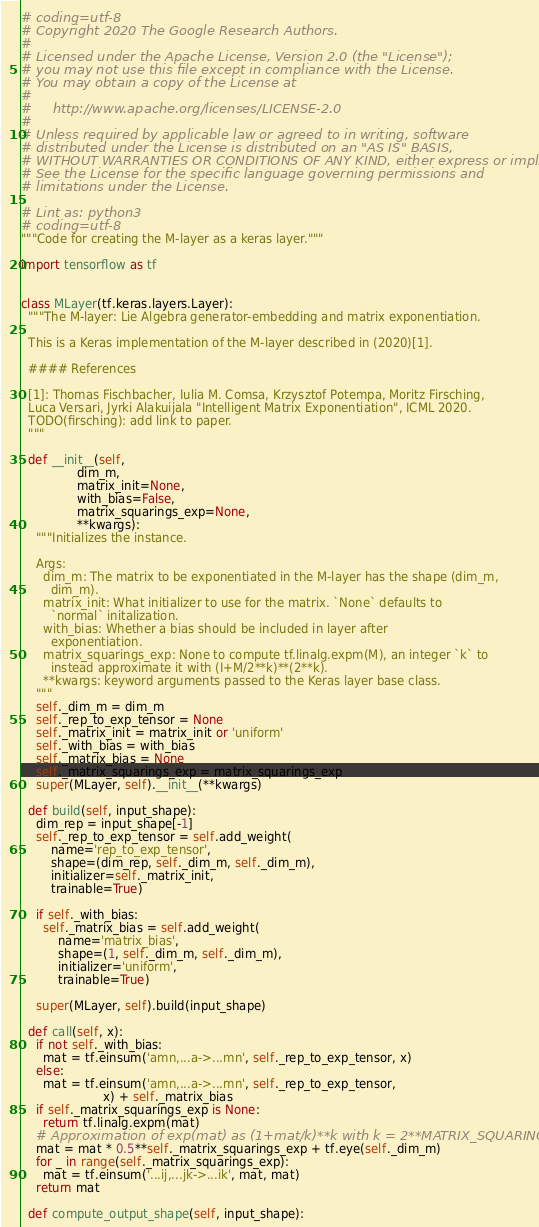Convert code to text. <code><loc_0><loc_0><loc_500><loc_500><_Python_># coding=utf-8
# Copyright 2020 The Google Research Authors.
#
# Licensed under the Apache License, Version 2.0 (the "License");
# you may not use this file except in compliance with the License.
# You may obtain a copy of the License at
#
#     http://www.apache.org/licenses/LICENSE-2.0
#
# Unless required by applicable law or agreed to in writing, software
# distributed under the License is distributed on an "AS IS" BASIS,
# WITHOUT WARRANTIES OR CONDITIONS OF ANY KIND, either express or implied.
# See the License for the specific language governing permissions and
# limitations under the License.

# Lint as: python3
# coding=utf-8
"""Code for creating the M-layer as a keras layer."""

import tensorflow as tf


class MLayer(tf.keras.layers.Layer):
  """The M-layer: Lie Algebra generator-embedding and matrix exponentiation.

  This is a Keras implementation of the M-layer described in (2020)[1].

  #### References

  [1]: Thomas Fischbacher, Iulia M. Comsa, Krzysztof Potempa, Moritz Firsching,
  Luca Versari, Jyrki Alakuijala "Intelligent Matrix Exponentiation", ICML 2020.
  TODO(firsching): add link to paper.
  """

  def __init__(self,
               dim_m,
               matrix_init=None,
               with_bias=False,
               matrix_squarings_exp=None,
               **kwargs):
    """Initializes the instance.

    Args:
      dim_m: The matrix to be exponentiated in the M-layer has the shape (dim_m,
        dim_m).
      matrix_init: What initializer to use for the matrix. `None` defaults to
        `normal` initalization.
      with_bias: Whether a bias should be included in layer after
        exponentiation.
      matrix_squarings_exp: None to compute tf.linalg.expm(M), an integer `k` to
        instead approximate it with (I+M/2**k)**(2**k).
      **kwargs: keyword arguments passed to the Keras layer base class.
    """
    self._dim_m = dim_m
    self._rep_to_exp_tensor = None
    self._matrix_init = matrix_init or 'uniform'
    self._with_bias = with_bias
    self._matrix_bias = None
    self._matrix_squarings_exp = matrix_squarings_exp
    super(MLayer, self).__init__(**kwargs)

  def build(self, input_shape):
    dim_rep = input_shape[-1]
    self._rep_to_exp_tensor = self.add_weight(
        name='rep_to_exp_tensor',
        shape=(dim_rep, self._dim_m, self._dim_m),
        initializer=self._matrix_init,
        trainable=True)

    if self._with_bias:
      self._matrix_bias = self.add_weight(
          name='matrix_bias',
          shape=(1, self._dim_m, self._dim_m),
          initializer='uniform',
          trainable=True)

    super(MLayer, self).build(input_shape)

  def call(self, x):
    if not self._with_bias:
      mat = tf.einsum('amn,...a->...mn', self._rep_to_exp_tensor, x)
    else:
      mat = tf.einsum('amn,...a->...mn', self._rep_to_exp_tensor,
                      x) + self._matrix_bias
    if self._matrix_squarings_exp is None:
      return tf.linalg.expm(mat)
    # Approximation of exp(mat) as (1+mat/k)**k with k = 2**MATRIX_SQUARINGS_EXP
    mat = mat * 0.5**self._matrix_squarings_exp + tf.eye(self._dim_m)
    for _ in range(self._matrix_squarings_exp):
      mat = tf.einsum('...ij,...jk->...ik', mat, mat)
    return mat

  def compute_output_shape(self, input_shape):</code> 